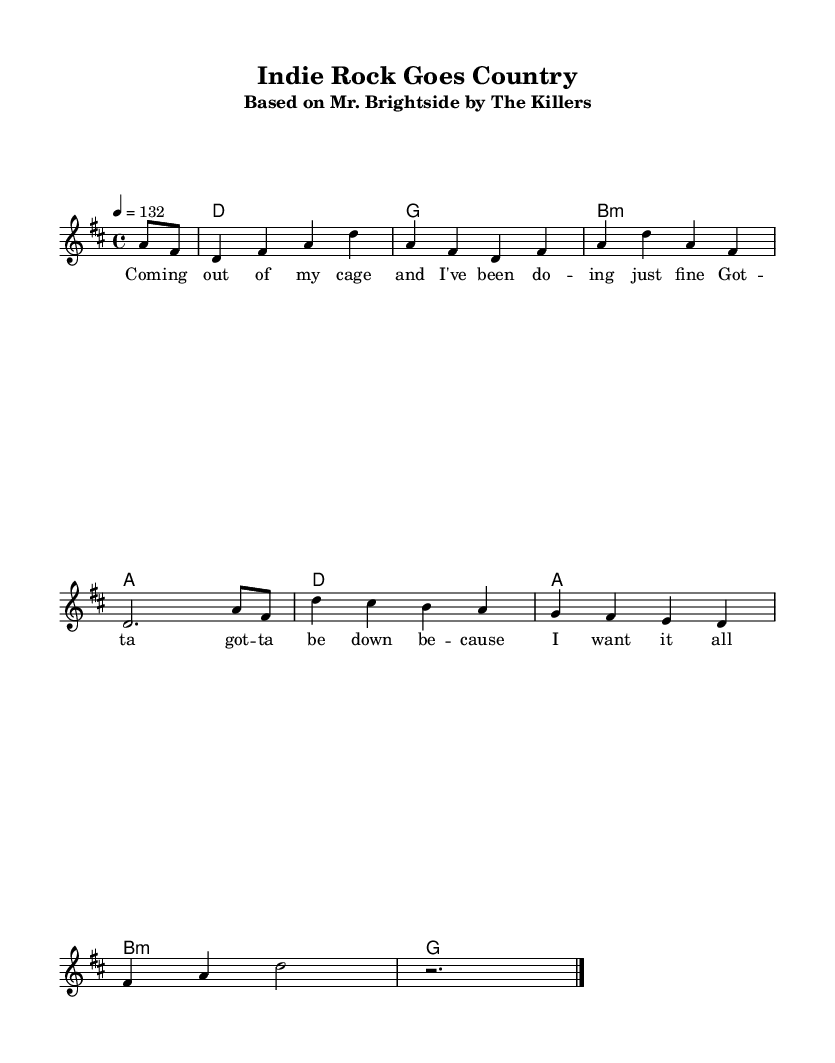What is the key signature of this music? The key signature is D major, which has two sharps (F# and C#). This is determined from the global settings at the beginning of the sheet music where the key is stated.
Answer: D major What is the time signature of this music? The time signature is 4/4, indicated in the global settings section of the score. This means there are four beats per measure, and the quarter note receives one beat.
Answer: 4/4 What is the tempo marking for this piece? The tempo marking is 132 beats per minute, which is indicated in the global section of the score, specifying how fast the piece should be played.
Answer: 132 How many measures are in the melody? The melody consists of 8 measures, as indicated by the number of bar lines in the melody notation, each separating the measures.
Answer: 8 What type of song is this arrangement based on? This arrangement is based on "Mr. Brightside" by The Killers, which is explicitly stated in the subtitle of the score.
Answer: Mr. Brightside What musical genre does this piece represent? This piece represents the Country Rock genre, which is inferred from the context of country rock covers of popular indie songs.
Answer: Country Rock 